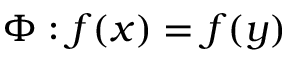Convert formula to latex. <formula><loc_0><loc_0><loc_500><loc_500>\Phi \colon f ( x ) = f ( y )</formula> 